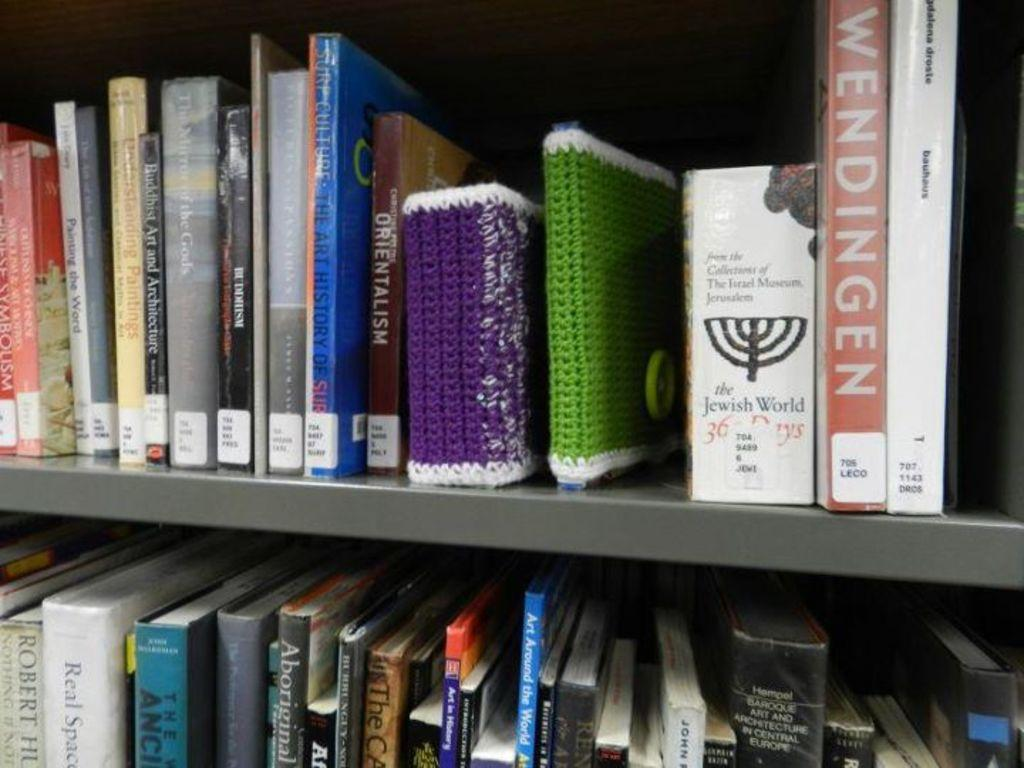<image>
Summarize the visual content of the image. A library bookshelf with spins of several books, one titled 'orientalism' 